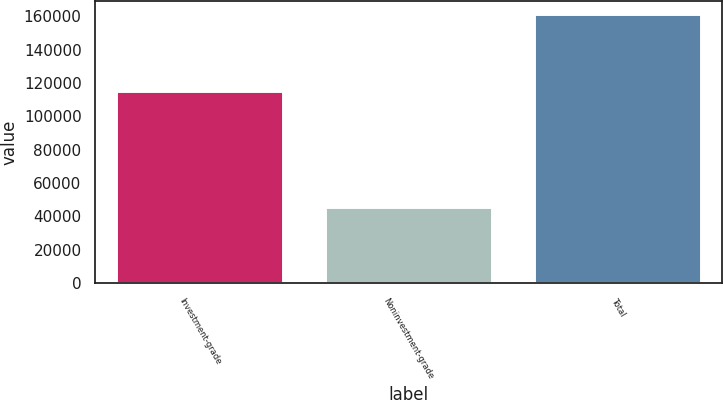Convert chart to OTSL. <chart><loc_0><loc_0><loc_500><loc_500><bar_chart><fcel>Investment-grade<fcel>Noninvestment-grade<fcel>Total<nl><fcel>115443<fcel>45897<fcel>161340<nl></chart> 